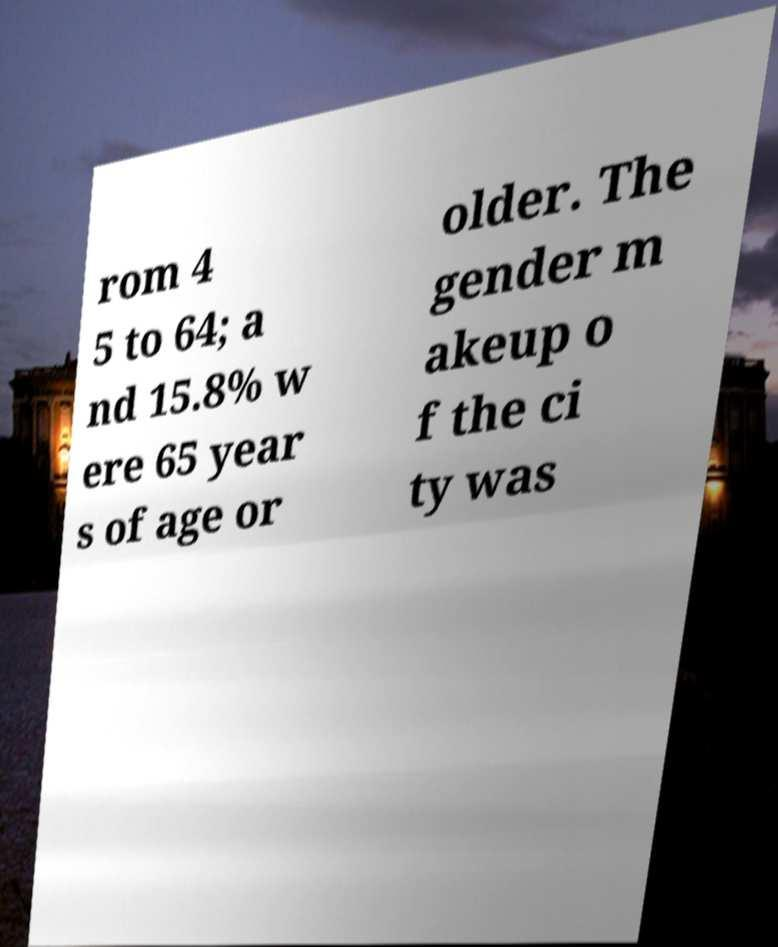Could you assist in decoding the text presented in this image and type it out clearly? rom 4 5 to 64; a nd 15.8% w ere 65 year s of age or older. The gender m akeup o f the ci ty was 